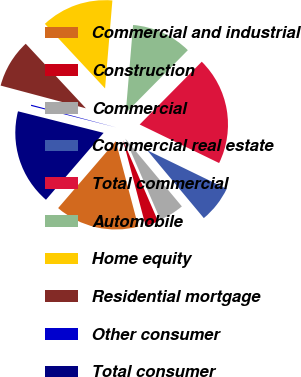Convert chart. <chart><loc_0><loc_0><loc_500><loc_500><pie_chart><fcel>Commercial and industrial<fcel>Construction<fcel>Commercial<fcel>Commercial real estate<fcel>Total commercial<fcel>Automobile<fcel>Home equity<fcel>Residential mortgage<fcel>Other consumer<fcel>Total consumer<nl><fcel>15.43%<fcel>2.39%<fcel>4.57%<fcel>6.74%<fcel>19.78%<fcel>11.09%<fcel>13.26%<fcel>8.91%<fcel>0.22%<fcel>17.61%<nl></chart> 